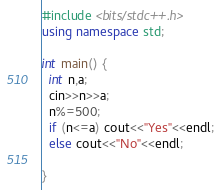<code> <loc_0><loc_0><loc_500><loc_500><_C++_>#include <bits/stdc++.h>
using namespace std;
 
int main() {
  int n,a;
  cin>>n>>a;
  n%=500;
  if (n<=a) cout<<"Yes"<<endl;
  else cout<<"No"<<endl;
 
}</code> 